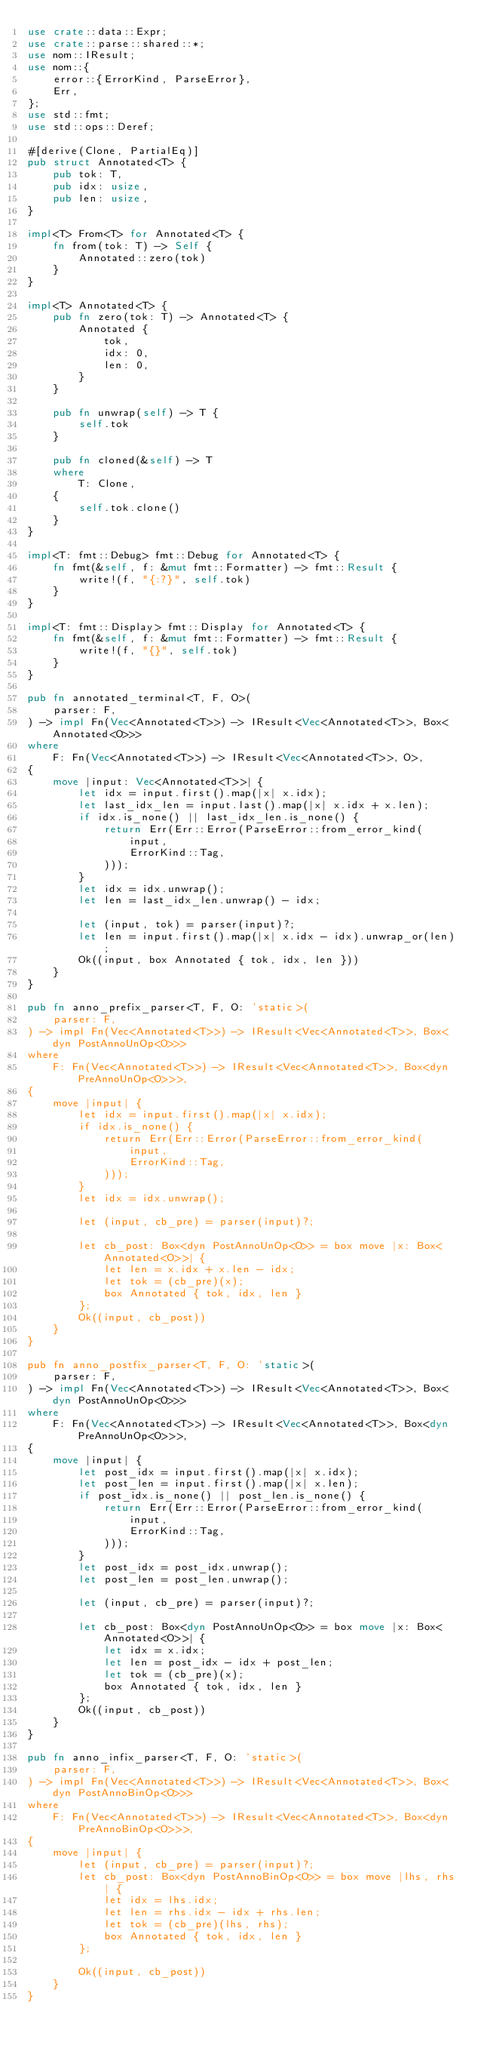<code> <loc_0><loc_0><loc_500><loc_500><_Rust_>use crate::data::Expr;
use crate::parse::shared::*;
use nom::IResult;
use nom::{
    error::{ErrorKind, ParseError},
    Err,
};
use std::fmt;
use std::ops::Deref;

#[derive(Clone, PartialEq)]
pub struct Annotated<T> {
    pub tok: T,
    pub idx: usize,
    pub len: usize,
}

impl<T> From<T> for Annotated<T> {
    fn from(tok: T) -> Self {
        Annotated::zero(tok)
    }
}

impl<T> Annotated<T> {
    pub fn zero(tok: T) -> Annotated<T> {
        Annotated {
            tok,
            idx: 0,
            len: 0,
        }
    }

    pub fn unwrap(self) -> T {
        self.tok
    }

    pub fn cloned(&self) -> T
    where
        T: Clone,
    {
        self.tok.clone()
    }
}

impl<T: fmt::Debug> fmt::Debug for Annotated<T> {
    fn fmt(&self, f: &mut fmt::Formatter) -> fmt::Result {
        write!(f, "{:?}", self.tok)
    }
}

impl<T: fmt::Display> fmt::Display for Annotated<T> {
    fn fmt(&self, f: &mut fmt::Formatter) -> fmt::Result {
        write!(f, "{}", self.tok)
    }
}

pub fn annotated_terminal<T, F, O>(
    parser: F,
) -> impl Fn(Vec<Annotated<T>>) -> IResult<Vec<Annotated<T>>, Box<Annotated<O>>>
where
    F: Fn(Vec<Annotated<T>>) -> IResult<Vec<Annotated<T>>, O>,
{
    move |input: Vec<Annotated<T>>| {
        let idx = input.first().map(|x| x.idx);
        let last_idx_len = input.last().map(|x| x.idx + x.len);
        if idx.is_none() || last_idx_len.is_none() {
            return Err(Err::Error(ParseError::from_error_kind(
                input,
                ErrorKind::Tag,
            )));
        }
        let idx = idx.unwrap();
        let len = last_idx_len.unwrap() - idx;

        let (input, tok) = parser(input)?;
        let len = input.first().map(|x| x.idx - idx).unwrap_or(len);
        Ok((input, box Annotated { tok, idx, len }))
    }
}

pub fn anno_prefix_parser<T, F, O: 'static>(
    parser: F,
) -> impl Fn(Vec<Annotated<T>>) -> IResult<Vec<Annotated<T>>, Box<dyn PostAnnoUnOp<O>>>
where
    F: Fn(Vec<Annotated<T>>) -> IResult<Vec<Annotated<T>>, Box<dyn PreAnnoUnOp<O>>>,
{
    move |input| {
        let idx = input.first().map(|x| x.idx);
        if idx.is_none() {
            return Err(Err::Error(ParseError::from_error_kind(
                input,
                ErrorKind::Tag,
            )));
        }
        let idx = idx.unwrap();

        let (input, cb_pre) = parser(input)?;

        let cb_post: Box<dyn PostAnnoUnOp<O>> = box move |x: Box<Annotated<O>>| {
            let len = x.idx + x.len - idx;
            let tok = (cb_pre)(x);
            box Annotated { tok, idx, len }
        };
        Ok((input, cb_post))
    }
}

pub fn anno_postfix_parser<T, F, O: 'static>(
    parser: F,
) -> impl Fn(Vec<Annotated<T>>) -> IResult<Vec<Annotated<T>>, Box<dyn PostAnnoUnOp<O>>>
where
    F: Fn(Vec<Annotated<T>>) -> IResult<Vec<Annotated<T>>, Box<dyn PreAnnoUnOp<O>>>,
{
    move |input| {
        let post_idx = input.first().map(|x| x.idx);
        let post_len = input.first().map(|x| x.len);
        if post_idx.is_none() || post_len.is_none() {
            return Err(Err::Error(ParseError::from_error_kind(
                input,
                ErrorKind::Tag,
            )));
        }
        let post_idx = post_idx.unwrap();
        let post_len = post_len.unwrap();

        let (input, cb_pre) = parser(input)?;

        let cb_post: Box<dyn PostAnnoUnOp<O>> = box move |x: Box<Annotated<O>>| {
            let idx = x.idx;
            let len = post_idx - idx + post_len;
            let tok = (cb_pre)(x);
            box Annotated { tok, idx, len }
        };
        Ok((input, cb_post))
    }
}

pub fn anno_infix_parser<T, F, O: 'static>(
    parser: F,
) -> impl Fn(Vec<Annotated<T>>) -> IResult<Vec<Annotated<T>>, Box<dyn PostAnnoBinOp<O>>>
where
    F: Fn(Vec<Annotated<T>>) -> IResult<Vec<Annotated<T>>, Box<dyn PreAnnoBinOp<O>>>,
{
    move |input| {
        let (input, cb_pre) = parser(input)?;
        let cb_post: Box<dyn PostAnnoBinOp<O>> = box move |lhs, rhs| {
            let idx = lhs.idx;
            let len = rhs.idx - idx + rhs.len;
            let tok = (cb_pre)(lhs, rhs);
            box Annotated { tok, idx, len }
        };

        Ok((input, cb_post))
    }
}
</code> 